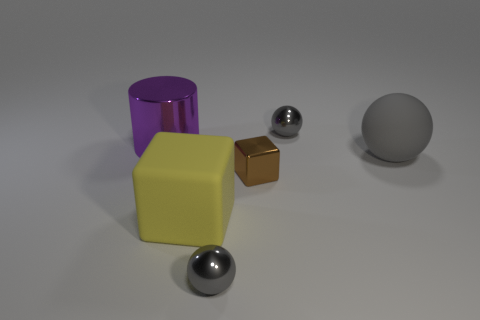Subtract all gray spheres. How many were subtracted if there are1gray spheres left? 2 Add 2 purple shiny objects. How many objects exist? 8 Subtract all cylinders. How many objects are left? 5 Add 5 metal spheres. How many metal spheres exist? 7 Subtract 1 purple cylinders. How many objects are left? 5 Subtract all yellow matte cubes. Subtract all small cyan matte things. How many objects are left? 5 Add 2 purple things. How many purple things are left? 3 